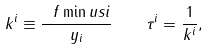<formula> <loc_0><loc_0><loc_500><loc_500>k ^ { i } \equiv \frac { \ f \min u s i } { y _ { i } } \quad \tau ^ { i } = \frac { 1 } { k ^ { i } } ,</formula> 